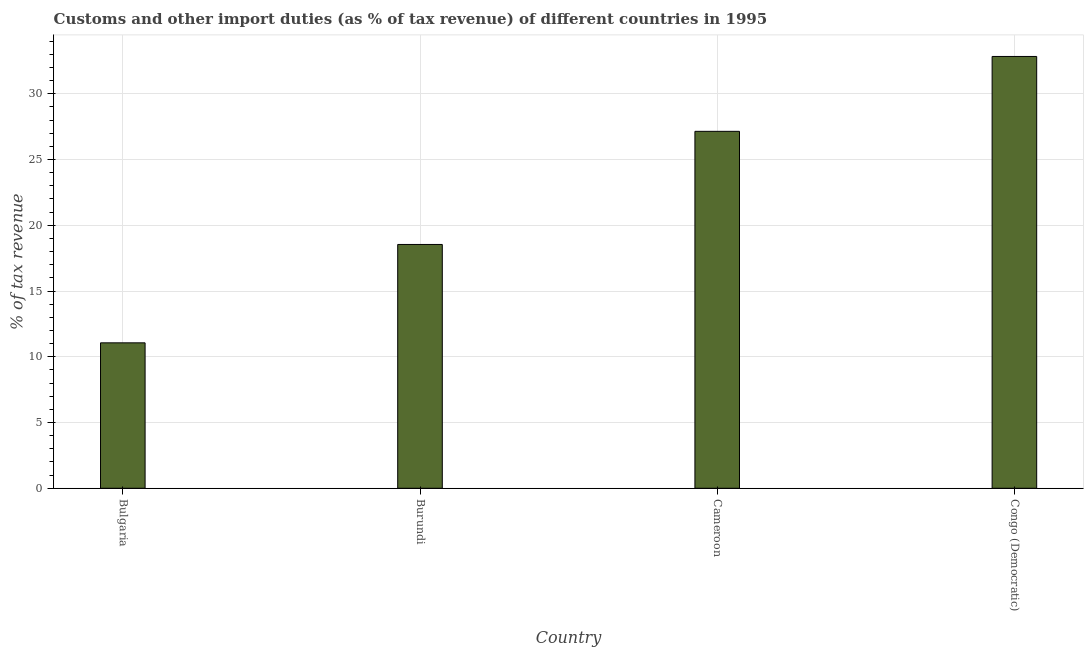Does the graph contain any zero values?
Keep it short and to the point. No. Does the graph contain grids?
Make the answer very short. Yes. What is the title of the graph?
Provide a short and direct response. Customs and other import duties (as % of tax revenue) of different countries in 1995. What is the label or title of the Y-axis?
Provide a short and direct response. % of tax revenue. What is the customs and other import duties in Bulgaria?
Your answer should be compact. 11.06. Across all countries, what is the maximum customs and other import duties?
Offer a very short reply. 32.84. Across all countries, what is the minimum customs and other import duties?
Your answer should be compact. 11.06. In which country was the customs and other import duties maximum?
Your answer should be compact. Congo (Democratic). What is the sum of the customs and other import duties?
Keep it short and to the point. 89.59. What is the difference between the customs and other import duties in Burundi and Congo (Democratic)?
Offer a very short reply. -14.3. What is the average customs and other import duties per country?
Keep it short and to the point. 22.4. What is the median customs and other import duties?
Ensure brevity in your answer.  22.84. What is the ratio of the customs and other import duties in Burundi to that in Cameroon?
Offer a very short reply. 0.68. What is the difference between the highest and the second highest customs and other import duties?
Your answer should be very brief. 5.69. Is the sum of the customs and other import duties in Cameroon and Congo (Democratic) greater than the maximum customs and other import duties across all countries?
Ensure brevity in your answer.  Yes. What is the difference between the highest and the lowest customs and other import duties?
Offer a terse response. 21.78. How many bars are there?
Offer a very short reply. 4. What is the difference between two consecutive major ticks on the Y-axis?
Your answer should be very brief. 5. What is the % of tax revenue of Bulgaria?
Keep it short and to the point. 11.06. What is the % of tax revenue in Burundi?
Your answer should be compact. 18.54. What is the % of tax revenue in Cameroon?
Your answer should be compact. 27.14. What is the % of tax revenue of Congo (Democratic)?
Provide a succinct answer. 32.84. What is the difference between the % of tax revenue in Bulgaria and Burundi?
Offer a terse response. -7.48. What is the difference between the % of tax revenue in Bulgaria and Cameroon?
Offer a very short reply. -16.08. What is the difference between the % of tax revenue in Bulgaria and Congo (Democratic)?
Provide a short and direct response. -21.78. What is the difference between the % of tax revenue in Burundi and Cameroon?
Provide a short and direct response. -8.6. What is the difference between the % of tax revenue in Burundi and Congo (Democratic)?
Provide a short and direct response. -14.3. What is the difference between the % of tax revenue in Cameroon and Congo (Democratic)?
Offer a very short reply. -5.69. What is the ratio of the % of tax revenue in Bulgaria to that in Burundi?
Provide a short and direct response. 0.6. What is the ratio of the % of tax revenue in Bulgaria to that in Cameroon?
Provide a succinct answer. 0.41. What is the ratio of the % of tax revenue in Bulgaria to that in Congo (Democratic)?
Offer a terse response. 0.34. What is the ratio of the % of tax revenue in Burundi to that in Cameroon?
Your response must be concise. 0.68. What is the ratio of the % of tax revenue in Burundi to that in Congo (Democratic)?
Provide a short and direct response. 0.56. What is the ratio of the % of tax revenue in Cameroon to that in Congo (Democratic)?
Make the answer very short. 0.83. 